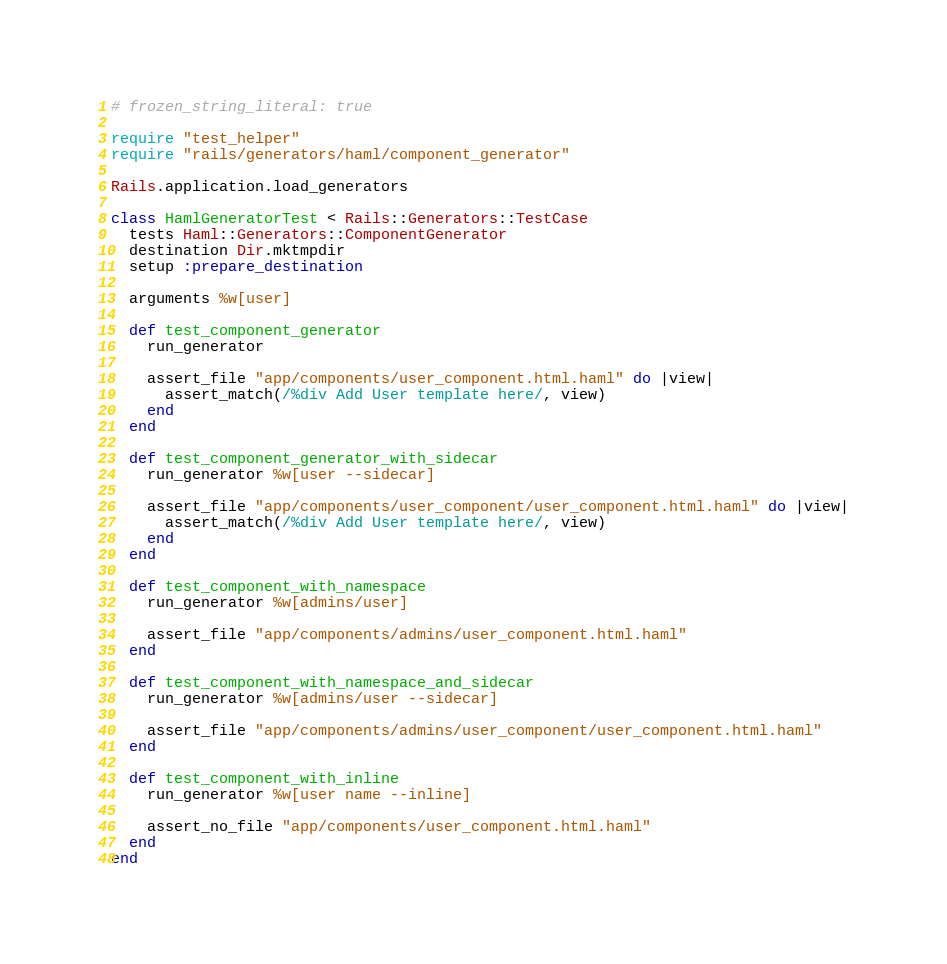Convert code to text. <code><loc_0><loc_0><loc_500><loc_500><_Ruby_># frozen_string_literal: true

require "test_helper"
require "rails/generators/haml/component_generator"

Rails.application.load_generators

class HamlGeneratorTest < Rails::Generators::TestCase
  tests Haml::Generators::ComponentGenerator
  destination Dir.mktmpdir
  setup :prepare_destination

  arguments %w[user]

  def test_component_generator
    run_generator

    assert_file "app/components/user_component.html.haml" do |view|
      assert_match(/%div Add User template here/, view)
    end
  end

  def test_component_generator_with_sidecar
    run_generator %w[user --sidecar]

    assert_file "app/components/user_component/user_component.html.haml" do |view|
      assert_match(/%div Add User template here/, view)
    end
  end

  def test_component_with_namespace
    run_generator %w[admins/user]

    assert_file "app/components/admins/user_component.html.haml"
  end

  def test_component_with_namespace_and_sidecar
    run_generator %w[admins/user --sidecar]

    assert_file "app/components/admins/user_component/user_component.html.haml"
  end

  def test_component_with_inline
    run_generator %w[user name --inline]

    assert_no_file "app/components/user_component.html.haml"
  end
end
</code> 